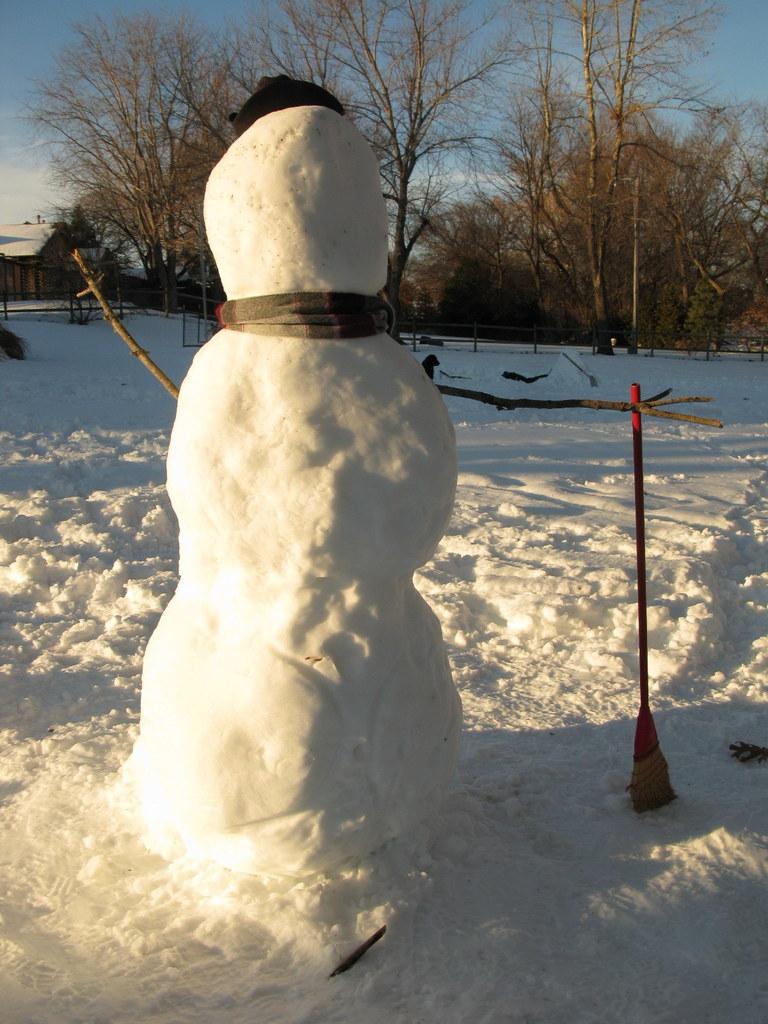Describe this image in one or two sentences. In this image we can see a snowman, in the background there are some trees, a house and a sky. 